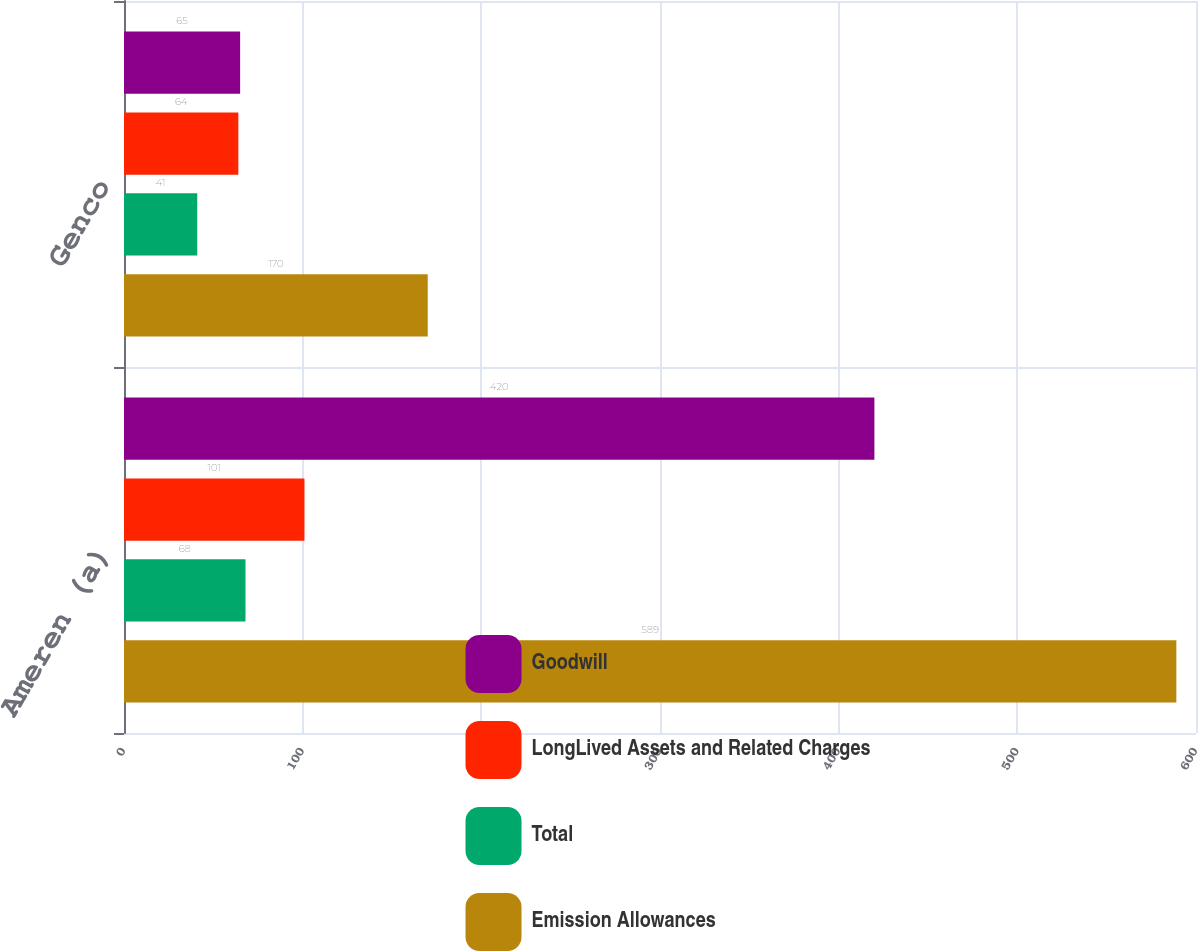Convert chart to OTSL. <chart><loc_0><loc_0><loc_500><loc_500><stacked_bar_chart><ecel><fcel>Ameren (a)<fcel>Genco<nl><fcel>Goodwill<fcel>420<fcel>65<nl><fcel>LongLived Assets and Related Charges<fcel>101<fcel>64<nl><fcel>Total<fcel>68<fcel>41<nl><fcel>Emission Allowances<fcel>589<fcel>170<nl></chart> 